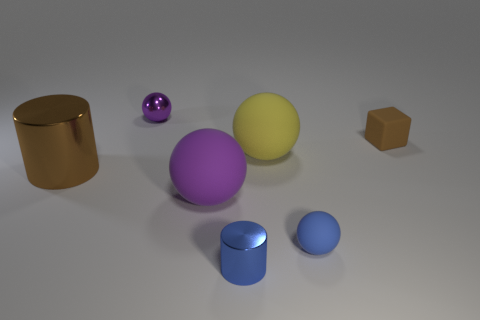Is the number of large brown things less than the number of big gray shiny balls?
Provide a succinct answer. No. There is another large thing that is the same shape as the blue metallic object; what is its color?
Provide a short and direct response. Brown. What color is the small sphere that is the same material as the large purple sphere?
Ensure brevity in your answer.  Blue. What number of rubber cubes have the same size as the brown rubber thing?
Ensure brevity in your answer.  0. What material is the large brown cylinder?
Provide a short and direct response. Metal. Are there more big brown shiny cylinders than small blue things?
Your answer should be compact. No. Does the small brown thing have the same shape as the yellow thing?
Your answer should be compact. No. Is there anything else that has the same shape as the tiny brown matte object?
Your answer should be very brief. No. There is a sphere in front of the large purple thing; is it the same color as the metallic cylinder that is on the left side of the large purple object?
Give a very brief answer. No. Is the number of brown matte blocks that are to the right of the blue matte ball less than the number of big yellow matte spheres on the left side of the brown matte block?
Provide a succinct answer. No. 